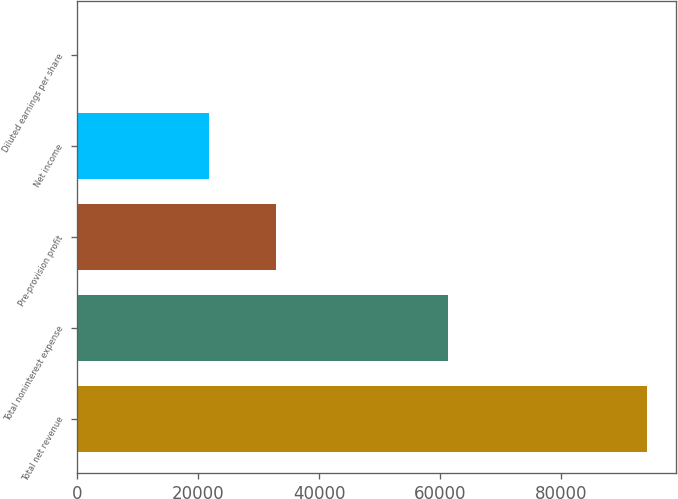Convert chart to OTSL. <chart><loc_0><loc_0><loc_500><loc_500><bar_chart><fcel>Total net revenue<fcel>Total noninterest expense<fcel>Pre-provision profit<fcel>Net income<fcel>Diluted earnings per share<nl><fcel>94205<fcel>61274<fcel>32931<fcel>21762<fcel>5.29<nl></chart> 